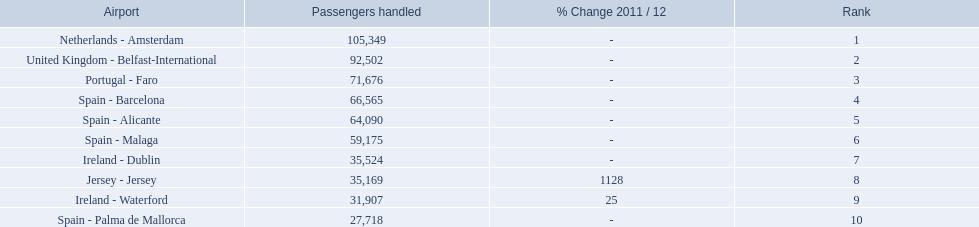What are all the airports in the top 10 busiest routes to and from london southend airport? Netherlands - Amsterdam, United Kingdom - Belfast-International, Portugal - Faro, Spain - Barcelona, Spain - Alicante, Spain - Malaga, Ireland - Dublin, Jersey - Jersey, Ireland - Waterford, Spain - Palma de Mallorca. Which airports are in portugal? Portugal - Faro. 